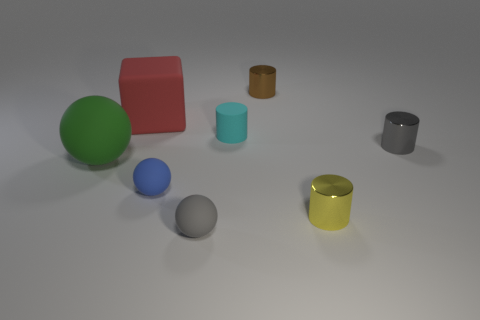Subtract 2 cylinders. How many cylinders are left? 2 Subtract all cyan cylinders. How many cylinders are left? 3 Subtract all small metal cylinders. How many cylinders are left? 1 Add 2 red matte objects. How many objects exist? 10 Subtract all green cylinders. Subtract all purple blocks. How many cylinders are left? 4 Subtract all blocks. How many objects are left? 7 Subtract all big green rubber cubes. Subtract all tiny brown cylinders. How many objects are left? 7 Add 6 tiny cylinders. How many tiny cylinders are left? 10 Add 7 tiny shiny cylinders. How many tiny shiny cylinders exist? 10 Subtract 0 purple cubes. How many objects are left? 8 